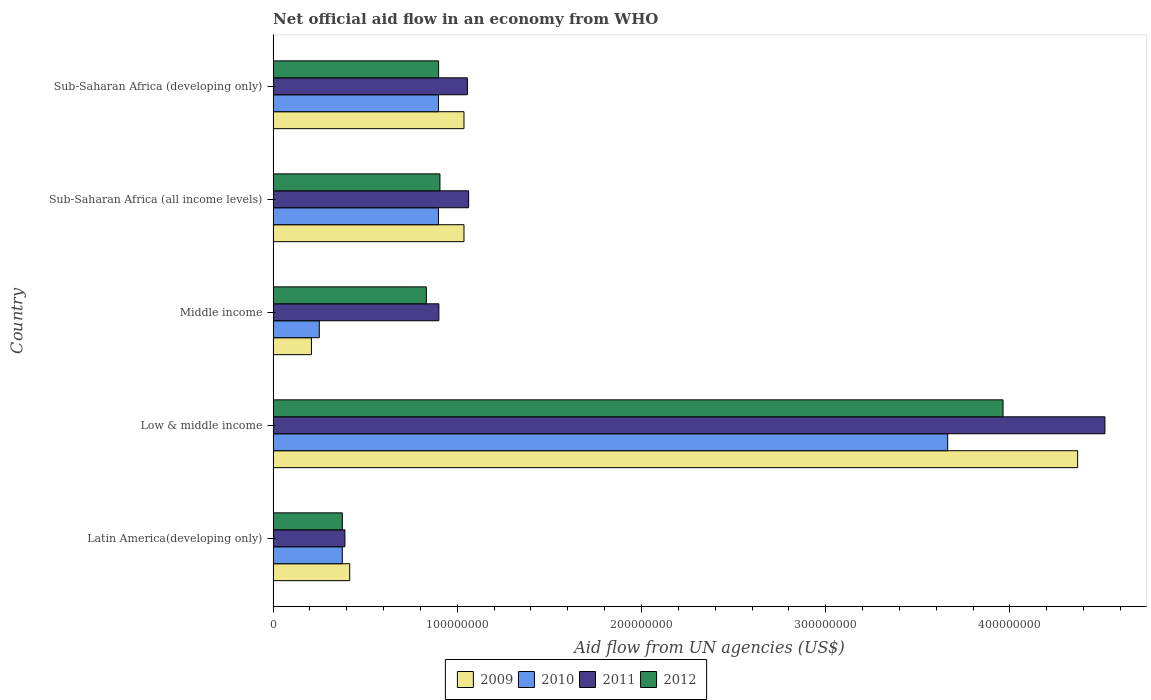How many groups of bars are there?
Keep it short and to the point. 5. How many bars are there on the 3rd tick from the bottom?
Provide a short and direct response. 4. In how many cases, is the number of bars for a given country not equal to the number of legend labels?
Ensure brevity in your answer.  0. What is the net official aid flow in 2011 in Low & middle income?
Ensure brevity in your answer.  4.52e+08. Across all countries, what is the maximum net official aid flow in 2009?
Your answer should be very brief. 4.37e+08. Across all countries, what is the minimum net official aid flow in 2009?
Your response must be concise. 2.08e+07. In which country was the net official aid flow in 2011 maximum?
Offer a very short reply. Low & middle income. In which country was the net official aid flow in 2010 minimum?
Your response must be concise. Middle income. What is the total net official aid flow in 2010 in the graph?
Your response must be concise. 6.08e+08. What is the difference between the net official aid flow in 2011 in Sub-Saharan Africa (all income levels) and that in Sub-Saharan Africa (developing only)?
Your response must be concise. 6.70e+05. What is the difference between the net official aid flow in 2011 in Middle income and the net official aid flow in 2010 in Low & middle income?
Give a very brief answer. -2.76e+08. What is the average net official aid flow in 2011 per country?
Offer a terse response. 1.58e+08. What is the difference between the net official aid flow in 2009 and net official aid flow in 2011 in Sub-Saharan Africa (developing only)?
Make the answer very short. -1.86e+06. What is the ratio of the net official aid flow in 2011 in Latin America(developing only) to that in Sub-Saharan Africa (all income levels)?
Offer a terse response. 0.37. Is the net official aid flow in 2009 in Low & middle income less than that in Sub-Saharan Africa (all income levels)?
Provide a short and direct response. No. What is the difference between the highest and the second highest net official aid flow in 2009?
Your answer should be very brief. 3.33e+08. What is the difference between the highest and the lowest net official aid flow in 2009?
Offer a very short reply. 4.16e+08. Is the sum of the net official aid flow in 2011 in Low & middle income and Middle income greater than the maximum net official aid flow in 2009 across all countries?
Keep it short and to the point. Yes. Is it the case that in every country, the sum of the net official aid flow in 2012 and net official aid flow in 2010 is greater than the sum of net official aid flow in 2011 and net official aid flow in 2009?
Offer a terse response. No. How many bars are there?
Provide a succinct answer. 20. Are all the bars in the graph horizontal?
Ensure brevity in your answer.  Yes. Are the values on the major ticks of X-axis written in scientific E-notation?
Your answer should be compact. No. Does the graph contain grids?
Offer a terse response. No. How many legend labels are there?
Offer a terse response. 4. How are the legend labels stacked?
Ensure brevity in your answer.  Horizontal. What is the title of the graph?
Ensure brevity in your answer.  Net official aid flow in an economy from WHO. Does "1978" appear as one of the legend labels in the graph?
Ensure brevity in your answer.  No. What is the label or title of the X-axis?
Your answer should be compact. Aid flow from UN agencies (US$). What is the Aid flow from UN agencies (US$) in 2009 in Latin America(developing only)?
Keep it short and to the point. 4.16e+07. What is the Aid flow from UN agencies (US$) in 2010 in Latin America(developing only)?
Make the answer very short. 3.76e+07. What is the Aid flow from UN agencies (US$) of 2011 in Latin America(developing only)?
Make the answer very short. 3.90e+07. What is the Aid flow from UN agencies (US$) in 2012 in Latin America(developing only)?
Keep it short and to the point. 3.76e+07. What is the Aid flow from UN agencies (US$) in 2009 in Low & middle income?
Your response must be concise. 4.37e+08. What is the Aid flow from UN agencies (US$) in 2010 in Low & middle income?
Ensure brevity in your answer.  3.66e+08. What is the Aid flow from UN agencies (US$) of 2011 in Low & middle income?
Offer a very short reply. 4.52e+08. What is the Aid flow from UN agencies (US$) in 2012 in Low & middle income?
Your response must be concise. 3.96e+08. What is the Aid flow from UN agencies (US$) in 2009 in Middle income?
Ensure brevity in your answer.  2.08e+07. What is the Aid flow from UN agencies (US$) of 2010 in Middle income?
Provide a succinct answer. 2.51e+07. What is the Aid flow from UN agencies (US$) in 2011 in Middle income?
Your response must be concise. 9.00e+07. What is the Aid flow from UN agencies (US$) of 2012 in Middle income?
Make the answer very short. 8.32e+07. What is the Aid flow from UN agencies (US$) in 2009 in Sub-Saharan Africa (all income levels)?
Your response must be concise. 1.04e+08. What is the Aid flow from UN agencies (US$) of 2010 in Sub-Saharan Africa (all income levels)?
Offer a very short reply. 8.98e+07. What is the Aid flow from UN agencies (US$) of 2011 in Sub-Saharan Africa (all income levels)?
Your answer should be compact. 1.06e+08. What is the Aid flow from UN agencies (US$) in 2012 in Sub-Saharan Africa (all income levels)?
Make the answer very short. 9.06e+07. What is the Aid flow from UN agencies (US$) of 2009 in Sub-Saharan Africa (developing only)?
Offer a terse response. 1.04e+08. What is the Aid flow from UN agencies (US$) in 2010 in Sub-Saharan Africa (developing only)?
Give a very brief answer. 8.98e+07. What is the Aid flow from UN agencies (US$) of 2011 in Sub-Saharan Africa (developing only)?
Your answer should be compact. 1.05e+08. What is the Aid flow from UN agencies (US$) of 2012 in Sub-Saharan Africa (developing only)?
Ensure brevity in your answer.  8.98e+07. Across all countries, what is the maximum Aid flow from UN agencies (US$) of 2009?
Keep it short and to the point. 4.37e+08. Across all countries, what is the maximum Aid flow from UN agencies (US$) in 2010?
Your answer should be compact. 3.66e+08. Across all countries, what is the maximum Aid flow from UN agencies (US$) of 2011?
Your response must be concise. 4.52e+08. Across all countries, what is the maximum Aid flow from UN agencies (US$) of 2012?
Offer a very short reply. 3.96e+08. Across all countries, what is the minimum Aid flow from UN agencies (US$) in 2009?
Offer a terse response. 2.08e+07. Across all countries, what is the minimum Aid flow from UN agencies (US$) in 2010?
Keep it short and to the point. 2.51e+07. Across all countries, what is the minimum Aid flow from UN agencies (US$) in 2011?
Offer a terse response. 3.90e+07. Across all countries, what is the minimum Aid flow from UN agencies (US$) in 2012?
Your answer should be very brief. 3.76e+07. What is the total Aid flow from UN agencies (US$) in 2009 in the graph?
Make the answer very short. 7.06e+08. What is the total Aid flow from UN agencies (US$) of 2010 in the graph?
Keep it short and to the point. 6.08e+08. What is the total Aid flow from UN agencies (US$) in 2011 in the graph?
Give a very brief answer. 7.92e+08. What is the total Aid flow from UN agencies (US$) in 2012 in the graph?
Provide a succinct answer. 6.97e+08. What is the difference between the Aid flow from UN agencies (US$) in 2009 in Latin America(developing only) and that in Low & middle income?
Give a very brief answer. -3.95e+08. What is the difference between the Aid flow from UN agencies (US$) in 2010 in Latin America(developing only) and that in Low & middle income?
Keep it short and to the point. -3.29e+08. What is the difference between the Aid flow from UN agencies (US$) in 2011 in Latin America(developing only) and that in Low & middle income?
Give a very brief answer. -4.13e+08. What is the difference between the Aid flow from UN agencies (US$) of 2012 in Latin America(developing only) and that in Low & middle income?
Offer a terse response. -3.59e+08. What is the difference between the Aid flow from UN agencies (US$) in 2009 in Latin America(developing only) and that in Middle income?
Offer a very short reply. 2.08e+07. What is the difference between the Aid flow from UN agencies (US$) in 2010 in Latin America(developing only) and that in Middle income?
Keep it short and to the point. 1.25e+07. What is the difference between the Aid flow from UN agencies (US$) in 2011 in Latin America(developing only) and that in Middle income?
Your response must be concise. -5.10e+07. What is the difference between the Aid flow from UN agencies (US$) in 2012 in Latin America(developing only) and that in Middle income?
Make the answer very short. -4.56e+07. What is the difference between the Aid flow from UN agencies (US$) in 2009 in Latin America(developing only) and that in Sub-Saharan Africa (all income levels)?
Your answer should be compact. -6.20e+07. What is the difference between the Aid flow from UN agencies (US$) of 2010 in Latin America(developing only) and that in Sub-Saharan Africa (all income levels)?
Offer a very short reply. -5.22e+07. What is the difference between the Aid flow from UN agencies (US$) in 2011 in Latin America(developing only) and that in Sub-Saharan Africa (all income levels)?
Keep it short and to the point. -6.72e+07. What is the difference between the Aid flow from UN agencies (US$) in 2012 in Latin America(developing only) and that in Sub-Saharan Africa (all income levels)?
Offer a very short reply. -5.30e+07. What is the difference between the Aid flow from UN agencies (US$) in 2009 in Latin America(developing only) and that in Sub-Saharan Africa (developing only)?
Provide a succinct answer. -6.20e+07. What is the difference between the Aid flow from UN agencies (US$) in 2010 in Latin America(developing only) and that in Sub-Saharan Africa (developing only)?
Ensure brevity in your answer.  -5.22e+07. What is the difference between the Aid flow from UN agencies (US$) of 2011 in Latin America(developing only) and that in Sub-Saharan Africa (developing only)?
Offer a very short reply. -6.65e+07. What is the difference between the Aid flow from UN agencies (US$) of 2012 in Latin America(developing only) and that in Sub-Saharan Africa (developing only)?
Your answer should be very brief. -5.23e+07. What is the difference between the Aid flow from UN agencies (US$) of 2009 in Low & middle income and that in Middle income?
Your response must be concise. 4.16e+08. What is the difference between the Aid flow from UN agencies (US$) of 2010 in Low & middle income and that in Middle income?
Provide a succinct answer. 3.41e+08. What is the difference between the Aid flow from UN agencies (US$) of 2011 in Low & middle income and that in Middle income?
Offer a terse response. 3.62e+08. What is the difference between the Aid flow from UN agencies (US$) in 2012 in Low & middle income and that in Middle income?
Your answer should be compact. 3.13e+08. What is the difference between the Aid flow from UN agencies (US$) of 2009 in Low & middle income and that in Sub-Saharan Africa (all income levels)?
Offer a terse response. 3.33e+08. What is the difference between the Aid flow from UN agencies (US$) in 2010 in Low & middle income and that in Sub-Saharan Africa (all income levels)?
Give a very brief answer. 2.76e+08. What is the difference between the Aid flow from UN agencies (US$) of 2011 in Low & middle income and that in Sub-Saharan Africa (all income levels)?
Offer a terse response. 3.45e+08. What is the difference between the Aid flow from UN agencies (US$) in 2012 in Low & middle income and that in Sub-Saharan Africa (all income levels)?
Provide a succinct answer. 3.06e+08. What is the difference between the Aid flow from UN agencies (US$) of 2009 in Low & middle income and that in Sub-Saharan Africa (developing only)?
Your answer should be very brief. 3.33e+08. What is the difference between the Aid flow from UN agencies (US$) in 2010 in Low & middle income and that in Sub-Saharan Africa (developing only)?
Keep it short and to the point. 2.76e+08. What is the difference between the Aid flow from UN agencies (US$) of 2011 in Low & middle income and that in Sub-Saharan Africa (developing only)?
Offer a very short reply. 3.46e+08. What is the difference between the Aid flow from UN agencies (US$) in 2012 in Low & middle income and that in Sub-Saharan Africa (developing only)?
Keep it short and to the point. 3.06e+08. What is the difference between the Aid flow from UN agencies (US$) in 2009 in Middle income and that in Sub-Saharan Africa (all income levels)?
Make the answer very short. -8.28e+07. What is the difference between the Aid flow from UN agencies (US$) of 2010 in Middle income and that in Sub-Saharan Africa (all income levels)?
Your answer should be very brief. -6.47e+07. What is the difference between the Aid flow from UN agencies (US$) of 2011 in Middle income and that in Sub-Saharan Africa (all income levels)?
Make the answer very short. -1.62e+07. What is the difference between the Aid flow from UN agencies (US$) in 2012 in Middle income and that in Sub-Saharan Africa (all income levels)?
Keep it short and to the point. -7.39e+06. What is the difference between the Aid flow from UN agencies (US$) of 2009 in Middle income and that in Sub-Saharan Africa (developing only)?
Your answer should be compact. -8.28e+07. What is the difference between the Aid flow from UN agencies (US$) of 2010 in Middle income and that in Sub-Saharan Africa (developing only)?
Keep it short and to the point. -6.47e+07. What is the difference between the Aid flow from UN agencies (US$) in 2011 in Middle income and that in Sub-Saharan Africa (developing only)?
Give a very brief answer. -1.55e+07. What is the difference between the Aid flow from UN agencies (US$) of 2012 in Middle income and that in Sub-Saharan Africa (developing only)?
Make the answer very short. -6.67e+06. What is the difference between the Aid flow from UN agencies (US$) in 2009 in Sub-Saharan Africa (all income levels) and that in Sub-Saharan Africa (developing only)?
Your answer should be compact. 0. What is the difference between the Aid flow from UN agencies (US$) of 2010 in Sub-Saharan Africa (all income levels) and that in Sub-Saharan Africa (developing only)?
Provide a succinct answer. 0. What is the difference between the Aid flow from UN agencies (US$) in 2011 in Sub-Saharan Africa (all income levels) and that in Sub-Saharan Africa (developing only)?
Your answer should be very brief. 6.70e+05. What is the difference between the Aid flow from UN agencies (US$) of 2012 in Sub-Saharan Africa (all income levels) and that in Sub-Saharan Africa (developing only)?
Offer a very short reply. 7.20e+05. What is the difference between the Aid flow from UN agencies (US$) in 2009 in Latin America(developing only) and the Aid flow from UN agencies (US$) in 2010 in Low & middle income?
Keep it short and to the point. -3.25e+08. What is the difference between the Aid flow from UN agencies (US$) of 2009 in Latin America(developing only) and the Aid flow from UN agencies (US$) of 2011 in Low & middle income?
Make the answer very short. -4.10e+08. What is the difference between the Aid flow from UN agencies (US$) of 2009 in Latin America(developing only) and the Aid flow from UN agencies (US$) of 2012 in Low & middle income?
Your response must be concise. -3.55e+08. What is the difference between the Aid flow from UN agencies (US$) of 2010 in Latin America(developing only) and the Aid flow from UN agencies (US$) of 2011 in Low & middle income?
Provide a short and direct response. -4.14e+08. What is the difference between the Aid flow from UN agencies (US$) of 2010 in Latin America(developing only) and the Aid flow from UN agencies (US$) of 2012 in Low & middle income?
Provide a succinct answer. -3.59e+08. What is the difference between the Aid flow from UN agencies (US$) of 2011 in Latin America(developing only) and the Aid flow from UN agencies (US$) of 2012 in Low & middle income?
Offer a very short reply. -3.57e+08. What is the difference between the Aid flow from UN agencies (US$) in 2009 in Latin America(developing only) and the Aid flow from UN agencies (US$) in 2010 in Middle income?
Make the answer very short. 1.65e+07. What is the difference between the Aid flow from UN agencies (US$) in 2009 in Latin America(developing only) and the Aid flow from UN agencies (US$) in 2011 in Middle income?
Your answer should be very brief. -4.84e+07. What is the difference between the Aid flow from UN agencies (US$) of 2009 in Latin America(developing only) and the Aid flow from UN agencies (US$) of 2012 in Middle income?
Your answer should be compact. -4.16e+07. What is the difference between the Aid flow from UN agencies (US$) in 2010 in Latin America(developing only) and the Aid flow from UN agencies (US$) in 2011 in Middle income?
Your answer should be very brief. -5.24e+07. What is the difference between the Aid flow from UN agencies (US$) in 2010 in Latin America(developing only) and the Aid flow from UN agencies (US$) in 2012 in Middle income?
Keep it short and to the point. -4.56e+07. What is the difference between the Aid flow from UN agencies (US$) in 2011 in Latin America(developing only) and the Aid flow from UN agencies (US$) in 2012 in Middle income?
Ensure brevity in your answer.  -4.42e+07. What is the difference between the Aid flow from UN agencies (US$) of 2009 in Latin America(developing only) and the Aid flow from UN agencies (US$) of 2010 in Sub-Saharan Africa (all income levels)?
Your answer should be compact. -4.82e+07. What is the difference between the Aid flow from UN agencies (US$) of 2009 in Latin America(developing only) and the Aid flow from UN agencies (US$) of 2011 in Sub-Saharan Africa (all income levels)?
Your response must be concise. -6.46e+07. What is the difference between the Aid flow from UN agencies (US$) in 2009 in Latin America(developing only) and the Aid flow from UN agencies (US$) in 2012 in Sub-Saharan Africa (all income levels)?
Your answer should be compact. -4.90e+07. What is the difference between the Aid flow from UN agencies (US$) of 2010 in Latin America(developing only) and the Aid flow from UN agencies (US$) of 2011 in Sub-Saharan Africa (all income levels)?
Provide a short and direct response. -6.86e+07. What is the difference between the Aid flow from UN agencies (US$) in 2010 in Latin America(developing only) and the Aid flow from UN agencies (US$) in 2012 in Sub-Saharan Africa (all income levels)?
Give a very brief answer. -5.30e+07. What is the difference between the Aid flow from UN agencies (US$) in 2011 in Latin America(developing only) and the Aid flow from UN agencies (US$) in 2012 in Sub-Saharan Africa (all income levels)?
Ensure brevity in your answer.  -5.16e+07. What is the difference between the Aid flow from UN agencies (US$) in 2009 in Latin America(developing only) and the Aid flow from UN agencies (US$) in 2010 in Sub-Saharan Africa (developing only)?
Keep it short and to the point. -4.82e+07. What is the difference between the Aid flow from UN agencies (US$) in 2009 in Latin America(developing only) and the Aid flow from UN agencies (US$) in 2011 in Sub-Saharan Africa (developing only)?
Ensure brevity in your answer.  -6.39e+07. What is the difference between the Aid flow from UN agencies (US$) of 2009 in Latin America(developing only) and the Aid flow from UN agencies (US$) of 2012 in Sub-Saharan Africa (developing only)?
Ensure brevity in your answer.  -4.83e+07. What is the difference between the Aid flow from UN agencies (US$) of 2010 in Latin America(developing only) and the Aid flow from UN agencies (US$) of 2011 in Sub-Saharan Africa (developing only)?
Offer a very short reply. -6.79e+07. What is the difference between the Aid flow from UN agencies (US$) of 2010 in Latin America(developing only) and the Aid flow from UN agencies (US$) of 2012 in Sub-Saharan Africa (developing only)?
Your response must be concise. -5.23e+07. What is the difference between the Aid flow from UN agencies (US$) of 2011 in Latin America(developing only) and the Aid flow from UN agencies (US$) of 2012 in Sub-Saharan Africa (developing only)?
Your answer should be very brief. -5.09e+07. What is the difference between the Aid flow from UN agencies (US$) of 2009 in Low & middle income and the Aid flow from UN agencies (US$) of 2010 in Middle income?
Provide a short and direct response. 4.12e+08. What is the difference between the Aid flow from UN agencies (US$) in 2009 in Low & middle income and the Aid flow from UN agencies (US$) in 2011 in Middle income?
Offer a terse response. 3.47e+08. What is the difference between the Aid flow from UN agencies (US$) in 2009 in Low & middle income and the Aid flow from UN agencies (US$) in 2012 in Middle income?
Offer a very short reply. 3.54e+08. What is the difference between the Aid flow from UN agencies (US$) of 2010 in Low & middle income and the Aid flow from UN agencies (US$) of 2011 in Middle income?
Provide a short and direct response. 2.76e+08. What is the difference between the Aid flow from UN agencies (US$) in 2010 in Low & middle income and the Aid flow from UN agencies (US$) in 2012 in Middle income?
Your answer should be very brief. 2.83e+08. What is the difference between the Aid flow from UN agencies (US$) of 2011 in Low & middle income and the Aid flow from UN agencies (US$) of 2012 in Middle income?
Your answer should be compact. 3.68e+08. What is the difference between the Aid flow from UN agencies (US$) of 2009 in Low & middle income and the Aid flow from UN agencies (US$) of 2010 in Sub-Saharan Africa (all income levels)?
Offer a very short reply. 3.47e+08. What is the difference between the Aid flow from UN agencies (US$) of 2009 in Low & middle income and the Aid flow from UN agencies (US$) of 2011 in Sub-Saharan Africa (all income levels)?
Give a very brief answer. 3.31e+08. What is the difference between the Aid flow from UN agencies (US$) in 2009 in Low & middle income and the Aid flow from UN agencies (US$) in 2012 in Sub-Saharan Africa (all income levels)?
Keep it short and to the point. 3.46e+08. What is the difference between the Aid flow from UN agencies (US$) in 2010 in Low & middle income and the Aid flow from UN agencies (US$) in 2011 in Sub-Saharan Africa (all income levels)?
Give a very brief answer. 2.60e+08. What is the difference between the Aid flow from UN agencies (US$) of 2010 in Low & middle income and the Aid flow from UN agencies (US$) of 2012 in Sub-Saharan Africa (all income levels)?
Your answer should be compact. 2.76e+08. What is the difference between the Aid flow from UN agencies (US$) of 2011 in Low & middle income and the Aid flow from UN agencies (US$) of 2012 in Sub-Saharan Africa (all income levels)?
Offer a very short reply. 3.61e+08. What is the difference between the Aid flow from UN agencies (US$) of 2009 in Low & middle income and the Aid flow from UN agencies (US$) of 2010 in Sub-Saharan Africa (developing only)?
Provide a succinct answer. 3.47e+08. What is the difference between the Aid flow from UN agencies (US$) in 2009 in Low & middle income and the Aid flow from UN agencies (US$) in 2011 in Sub-Saharan Africa (developing only)?
Your response must be concise. 3.31e+08. What is the difference between the Aid flow from UN agencies (US$) of 2009 in Low & middle income and the Aid flow from UN agencies (US$) of 2012 in Sub-Saharan Africa (developing only)?
Provide a succinct answer. 3.47e+08. What is the difference between the Aid flow from UN agencies (US$) in 2010 in Low & middle income and the Aid flow from UN agencies (US$) in 2011 in Sub-Saharan Africa (developing only)?
Give a very brief answer. 2.61e+08. What is the difference between the Aid flow from UN agencies (US$) of 2010 in Low & middle income and the Aid flow from UN agencies (US$) of 2012 in Sub-Saharan Africa (developing only)?
Your response must be concise. 2.76e+08. What is the difference between the Aid flow from UN agencies (US$) of 2011 in Low & middle income and the Aid flow from UN agencies (US$) of 2012 in Sub-Saharan Africa (developing only)?
Give a very brief answer. 3.62e+08. What is the difference between the Aid flow from UN agencies (US$) of 2009 in Middle income and the Aid flow from UN agencies (US$) of 2010 in Sub-Saharan Africa (all income levels)?
Your answer should be compact. -6.90e+07. What is the difference between the Aid flow from UN agencies (US$) of 2009 in Middle income and the Aid flow from UN agencies (US$) of 2011 in Sub-Saharan Africa (all income levels)?
Offer a very short reply. -8.54e+07. What is the difference between the Aid flow from UN agencies (US$) of 2009 in Middle income and the Aid flow from UN agencies (US$) of 2012 in Sub-Saharan Africa (all income levels)?
Offer a terse response. -6.98e+07. What is the difference between the Aid flow from UN agencies (US$) in 2010 in Middle income and the Aid flow from UN agencies (US$) in 2011 in Sub-Saharan Africa (all income levels)?
Give a very brief answer. -8.11e+07. What is the difference between the Aid flow from UN agencies (US$) of 2010 in Middle income and the Aid flow from UN agencies (US$) of 2012 in Sub-Saharan Africa (all income levels)?
Offer a terse response. -6.55e+07. What is the difference between the Aid flow from UN agencies (US$) of 2011 in Middle income and the Aid flow from UN agencies (US$) of 2012 in Sub-Saharan Africa (all income levels)?
Provide a succinct answer. -5.90e+05. What is the difference between the Aid flow from UN agencies (US$) of 2009 in Middle income and the Aid flow from UN agencies (US$) of 2010 in Sub-Saharan Africa (developing only)?
Ensure brevity in your answer.  -6.90e+07. What is the difference between the Aid flow from UN agencies (US$) in 2009 in Middle income and the Aid flow from UN agencies (US$) in 2011 in Sub-Saharan Africa (developing only)?
Give a very brief answer. -8.47e+07. What is the difference between the Aid flow from UN agencies (US$) in 2009 in Middle income and the Aid flow from UN agencies (US$) in 2012 in Sub-Saharan Africa (developing only)?
Offer a terse response. -6.90e+07. What is the difference between the Aid flow from UN agencies (US$) in 2010 in Middle income and the Aid flow from UN agencies (US$) in 2011 in Sub-Saharan Africa (developing only)?
Offer a very short reply. -8.04e+07. What is the difference between the Aid flow from UN agencies (US$) in 2010 in Middle income and the Aid flow from UN agencies (US$) in 2012 in Sub-Saharan Africa (developing only)?
Keep it short and to the point. -6.48e+07. What is the difference between the Aid flow from UN agencies (US$) of 2011 in Middle income and the Aid flow from UN agencies (US$) of 2012 in Sub-Saharan Africa (developing only)?
Your response must be concise. 1.30e+05. What is the difference between the Aid flow from UN agencies (US$) of 2009 in Sub-Saharan Africa (all income levels) and the Aid flow from UN agencies (US$) of 2010 in Sub-Saharan Africa (developing only)?
Your answer should be compact. 1.39e+07. What is the difference between the Aid flow from UN agencies (US$) of 2009 in Sub-Saharan Africa (all income levels) and the Aid flow from UN agencies (US$) of 2011 in Sub-Saharan Africa (developing only)?
Offer a very short reply. -1.86e+06. What is the difference between the Aid flow from UN agencies (US$) of 2009 in Sub-Saharan Africa (all income levels) and the Aid flow from UN agencies (US$) of 2012 in Sub-Saharan Africa (developing only)?
Ensure brevity in your answer.  1.38e+07. What is the difference between the Aid flow from UN agencies (US$) in 2010 in Sub-Saharan Africa (all income levels) and the Aid flow from UN agencies (US$) in 2011 in Sub-Saharan Africa (developing only)?
Offer a very short reply. -1.57e+07. What is the difference between the Aid flow from UN agencies (US$) of 2011 in Sub-Saharan Africa (all income levels) and the Aid flow from UN agencies (US$) of 2012 in Sub-Saharan Africa (developing only)?
Your answer should be very brief. 1.63e+07. What is the average Aid flow from UN agencies (US$) of 2009 per country?
Keep it short and to the point. 1.41e+08. What is the average Aid flow from UN agencies (US$) of 2010 per country?
Keep it short and to the point. 1.22e+08. What is the average Aid flow from UN agencies (US$) of 2011 per country?
Provide a succinct answer. 1.58e+08. What is the average Aid flow from UN agencies (US$) in 2012 per country?
Make the answer very short. 1.39e+08. What is the difference between the Aid flow from UN agencies (US$) of 2009 and Aid flow from UN agencies (US$) of 2010 in Latin America(developing only)?
Keep it short and to the point. 4.01e+06. What is the difference between the Aid flow from UN agencies (US$) of 2009 and Aid flow from UN agencies (US$) of 2011 in Latin America(developing only)?
Provide a short and direct response. 2.59e+06. What is the difference between the Aid flow from UN agencies (US$) in 2009 and Aid flow from UN agencies (US$) in 2012 in Latin America(developing only)?
Ensure brevity in your answer.  3.99e+06. What is the difference between the Aid flow from UN agencies (US$) in 2010 and Aid flow from UN agencies (US$) in 2011 in Latin America(developing only)?
Your response must be concise. -1.42e+06. What is the difference between the Aid flow from UN agencies (US$) of 2011 and Aid flow from UN agencies (US$) of 2012 in Latin America(developing only)?
Your answer should be compact. 1.40e+06. What is the difference between the Aid flow from UN agencies (US$) in 2009 and Aid flow from UN agencies (US$) in 2010 in Low & middle income?
Offer a terse response. 7.06e+07. What is the difference between the Aid flow from UN agencies (US$) in 2009 and Aid flow from UN agencies (US$) in 2011 in Low & middle income?
Ensure brevity in your answer.  -1.48e+07. What is the difference between the Aid flow from UN agencies (US$) in 2009 and Aid flow from UN agencies (US$) in 2012 in Low & middle income?
Ensure brevity in your answer.  4.05e+07. What is the difference between the Aid flow from UN agencies (US$) in 2010 and Aid flow from UN agencies (US$) in 2011 in Low & middle income?
Offer a very short reply. -8.54e+07. What is the difference between the Aid flow from UN agencies (US$) in 2010 and Aid flow from UN agencies (US$) in 2012 in Low & middle income?
Ensure brevity in your answer.  -3.00e+07. What is the difference between the Aid flow from UN agencies (US$) in 2011 and Aid flow from UN agencies (US$) in 2012 in Low & middle income?
Your response must be concise. 5.53e+07. What is the difference between the Aid flow from UN agencies (US$) in 2009 and Aid flow from UN agencies (US$) in 2010 in Middle income?
Make the answer very short. -4.27e+06. What is the difference between the Aid flow from UN agencies (US$) in 2009 and Aid flow from UN agencies (US$) in 2011 in Middle income?
Provide a short and direct response. -6.92e+07. What is the difference between the Aid flow from UN agencies (US$) of 2009 and Aid flow from UN agencies (US$) of 2012 in Middle income?
Make the answer very short. -6.24e+07. What is the difference between the Aid flow from UN agencies (US$) of 2010 and Aid flow from UN agencies (US$) of 2011 in Middle income?
Offer a terse response. -6.49e+07. What is the difference between the Aid flow from UN agencies (US$) in 2010 and Aid flow from UN agencies (US$) in 2012 in Middle income?
Give a very brief answer. -5.81e+07. What is the difference between the Aid flow from UN agencies (US$) of 2011 and Aid flow from UN agencies (US$) of 2012 in Middle income?
Provide a short and direct response. 6.80e+06. What is the difference between the Aid flow from UN agencies (US$) of 2009 and Aid flow from UN agencies (US$) of 2010 in Sub-Saharan Africa (all income levels)?
Make the answer very short. 1.39e+07. What is the difference between the Aid flow from UN agencies (US$) of 2009 and Aid flow from UN agencies (US$) of 2011 in Sub-Saharan Africa (all income levels)?
Provide a succinct answer. -2.53e+06. What is the difference between the Aid flow from UN agencies (US$) of 2009 and Aid flow from UN agencies (US$) of 2012 in Sub-Saharan Africa (all income levels)?
Keep it short and to the point. 1.30e+07. What is the difference between the Aid flow from UN agencies (US$) of 2010 and Aid flow from UN agencies (US$) of 2011 in Sub-Saharan Africa (all income levels)?
Ensure brevity in your answer.  -1.64e+07. What is the difference between the Aid flow from UN agencies (US$) in 2010 and Aid flow from UN agencies (US$) in 2012 in Sub-Saharan Africa (all income levels)?
Your answer should be compact. -8.10e+05. What is the difference between the Aid flow from UN agencies (US$) of 2011 and Aid flow from UN agencies (US$) of 2012 in Sub-Saharan Africa (all income levels)?
Keep it short and to the point. 1.56e+07. What is the difference between the Aid flow from UN agencies (US$) of 2009 and Aid flow from UN agencies (US$) of 2010 in Sub-Saharan Africa (developing only)?
Your response must be concise. 1.39e+07. What is the difference between the Aid flow from UN agencies (US$) in 2009 and Aid flow from UN agencies (US$) in 2011 in Sub-Saharan Africa (developing only)?
Offer a very short reply. -1.86e+06. What is the difference between the Aid flow from UN agencies (US$) in 2009 and Aid flow from UN agencies (US$) in 2012 in Sub-Saharan Africa (developing only)?
Provide a short and direct response. 1.38e+07. What is the difference between the Aid flow from UN agencies (US$) in 2010 and Aid flow from UN agencies (US$) in 2011 in Sub-Saharan Africa (developing only)?
Offer a very short reply. -1.57e+07. What is the difference between the Aid flow from UN agencies (US$) of 2010 and Aid flow from UN agencies (US$) of 2012 in Sub-Saharan Africa (developing only)?
Keep it short and to the point. -9.00e+04. What is the difference between the Aid flow from UN agencies (US$) of 2011 and Aid flow from UN agencies (US$) of 2012 in Sub-Saharan Africa (developing only)?
Your answer should be compact. 1.56e+07. What is the ratio of the Aid flow from UN agencies (US$) of 2009 in Latin America(developing only) to that in Low & middle income?
Give a very brief answer. 0.1. What is the ratio of the Aid flow from UN agencies (US$) of 2010 in Latin America(developing only) to that in Low & middle income?
Your answer should be compact. 0.1. What is the ratio of the Aid flow from UN agencies (US$) of 2011 in Latin America(developing only) to that in Low & middle income?
Make the answer very short. 0.09. What is the ratio of the Aid flow from UN agencies (US$) of 2012 in Latin America(developing only) to that in Low & middle income?
Give a very brief answer. 0.09. What is the ratio of the Aid flow from UN agencies (US$) of 2009 in Latin America(developing only) to that in Middle income?
Offer a very short reply. 2. What is the ratio of the Aid flow from UN agencies (US$) of 2010 in Latin America(developing only) to that in Middle income?
Offer a very short reply. 1.5. What is the ratio of the Aid flow from UN agencies (US$) in 2011 in Latin America(developing only) to that in Middle income?
Keep it short and to the point. 0.43. What is the ratio of the Aid flow from UN agencies (US$) of 2012 in Latin America(developing only) to that in Middle income?
Make the answer very short. 0.45. What is the ratio of the Aid flow from UN agencies (US$) of 2009 in Latin America(developing only) to that in Sub-Saharan Africa (all income levels)?
Make the answer very short. 0.4. What is the ratio of the Aid flow from UN agencies (US$) in 2010 in Latin America(developing only) to that in Sub-Saharan Africa (all income levels)?
Offer a very short reply. 0.42. What is the ratio of the Aid flow from UN agencies (US$) of 2011 in Latin America(developing only) to that in Sub-Saharan Africa (all income levels)?
Your response must be concise. 0.37. What is the ratio of the Aid flow from UN agencies (US$) of 2012 in Latin America(developing only) to that in Sub-Saharan Africa (all income levels)?
Give a very brief answer. 0.41. What is the ratio of the Aid flow from UN agencies (US$) in 2009 in Latin America(developing only) to that in Sub-Saharan Africa (developing only)?
Offer a very short reply. 0.4. What is the ratio of the Aid flow from UN agencies (US$) of 2010 in Latin America(developing only) to that in Sub-Saharan Africa (developing only)?
Offer a very short reply. 0.42. What is the ratio of the Aid flow from UN agencies (US$) in 2011 in Latin America(developing only) to that in Sub-Saharan Africa (developing only)?
Your answer should be very brief. 0.37. What is the ratio of the Aid flow from UN agencies (US$) in 2012 in Latin America(developing only) to that in Sub-Saharan Africa (developing only)?
Offer a terse response. 0.42. What is the ratio of the Aid flow from UN agencies (US$) in 2009 in Low & middle income to that in Middle income?
Keep it short and to the point. 21. What is the ratio of the Aid flow from UN agencies (US$) of 2010 in Low & middle income to that in Middle income?
Keep it short and to the point. 14.61. What is the ratio of the Aid flow from UN agencies (US$) of 2011 in Low & middle income to that in Middle income?
Offer a very short reply. 5.02. What is the ratio of the Aid flow from UN agencies (US$) in 2012 in Low & middle income to that in Middle income?
Give a very brief answer. 4.76. What is the ratio of the Aid flow from UN agencies (US$) of 2009 in Low & middle income to that in Sub-Saharan Africa (all income levels)?
Offer a very short reply. 4.22. What is the ratio of the Aid flow from UN agencies (US$) in 2010 in Low & middle income to that in Sub-Saharan Africa (all income levels)?
Your answer should be very brief. 4.08. What is the ratio of the Aid flow from UN agencies (US$) of 2011 in Low & middle income to that in Sub-Saharan Africa (all income levels)?
Keep it short and to the point. 4.25. What is the ratio of the Aid flow from UN agencies (US$) of 2012 in Low & middle income to that in Sub-Saharan Africa (all income levels)?
Keep it short and to the point. 4.38. What is the ratio of the Aid flow from UN agencies (US$) in 2009 in Low & middle income to that in Sub-Saharan Africa (developing only)?
Offer a terse response. 4.22. What is the ratio of the Aid flow from UN agencies (US$) in 2010 in Low & middle income to that in Sub-Saharan Africa (developing only)?
Give a very brief answer. 4.08. What is the ratio of the Aid flow from UN agencies (US$) in 2011 in Low & middle income to that in Sub-Saharan Africa (developing only)?
Your response must be concise. 4.28. What is the ratio of the Aid flow from UN agencies (US$) in 2012 in Low & middle income to that in Sub-Saharan Africa (developing only)?
Make the answer very short. 4.41. What is the ratio of the Aid flow from UN agencies (US$) of 2009 in Middle income to that in Sub-Saharan Africa (all income levels)?
Your response must be concise. 0.2. What is the ratio of the Aid flow from UN agencies (US$) in 2010 in Middle income to that in Sub-Saharan Africa (all income levels)?
Ensure brevity in your answer.  0.28. What is the ratio of the Aid flow from UN agencies (US$) in 2011 in Middle income to that in Sub-Saharan Africa (all income levels)?
Keep it short and to the point. 0.85. What is the ratio of the Aid flow from UN agencies (US$) in 2012 in Middle income to that in Sub-Saharan Africa (all income levels)?
Provide a short and direct response. 0.92. What is the ratio of the Aid flow from UN agencies (US$) of 2009 in Middle income to that in Sub-Saharan Africa (developing only)?
Give a very brief answer. 0.2. What is the ratio of the Aid flow from UN agencies (US$) in 2010 in Middle income to that in Sub-Saharan Africa (developing only)?
Provide a succinct answer. 0.28. What is the ratio of the Aid flow from UN agencies (US$) of 2011 in Middle income to that in Sub-Saharan Africa (developing only)?
Offer a very short reply. 0.85. What is the ratio of the Aid flow from UN agencies (US$) in 2012 in Middle income to that in Sub-Saharan Africa (developing only)?
Give a very brief answer. 0.93. What is the ratio of the Aid flow from UN agencies (US$) in 2011 in Sub-Saharan Africa (all income levels) to that in Sub-Saharan Africa (developing only)?
Your answer should be very brief. 1.01. What is the difference between the highest and the second highest Aid flow from UN agencies (US$) of 2009?
Your answer should be very brief. 3.33e+08. What is the difference between the highest and the second highest Aid flow from UN agencies (US$) of 2010?
Give a very brief answer. 2.76e+08. What is the difference between the highest and the second highest Aid flow from UN agencies (US$) in 2011?
Offer a terse response. 3.45e+08. What is the difference between the highest and the second highest Aid flow from UN agencies (US$) of 2012?
Offer a very short reply. 3.06e+08. What is the difference between the highest and the lowest Aid flow from UN agencies (US$) in 2009?
Your response must be concise. 4.16e+08. What is the difference between the highest and the lowest Aid flow from UN agencies (US$) of 2010?
Offer a terse response. 3.41e+08. What is the difference between the highest and the lowest Aid flow from UN agencies (US$) of 2011?
Make the answer very short. 4.13e+08. What is the difference between the highest and the lowest Aid flow from UN agencies (US$) of 2012?
Offer a very short reply. 3.59e+08. 